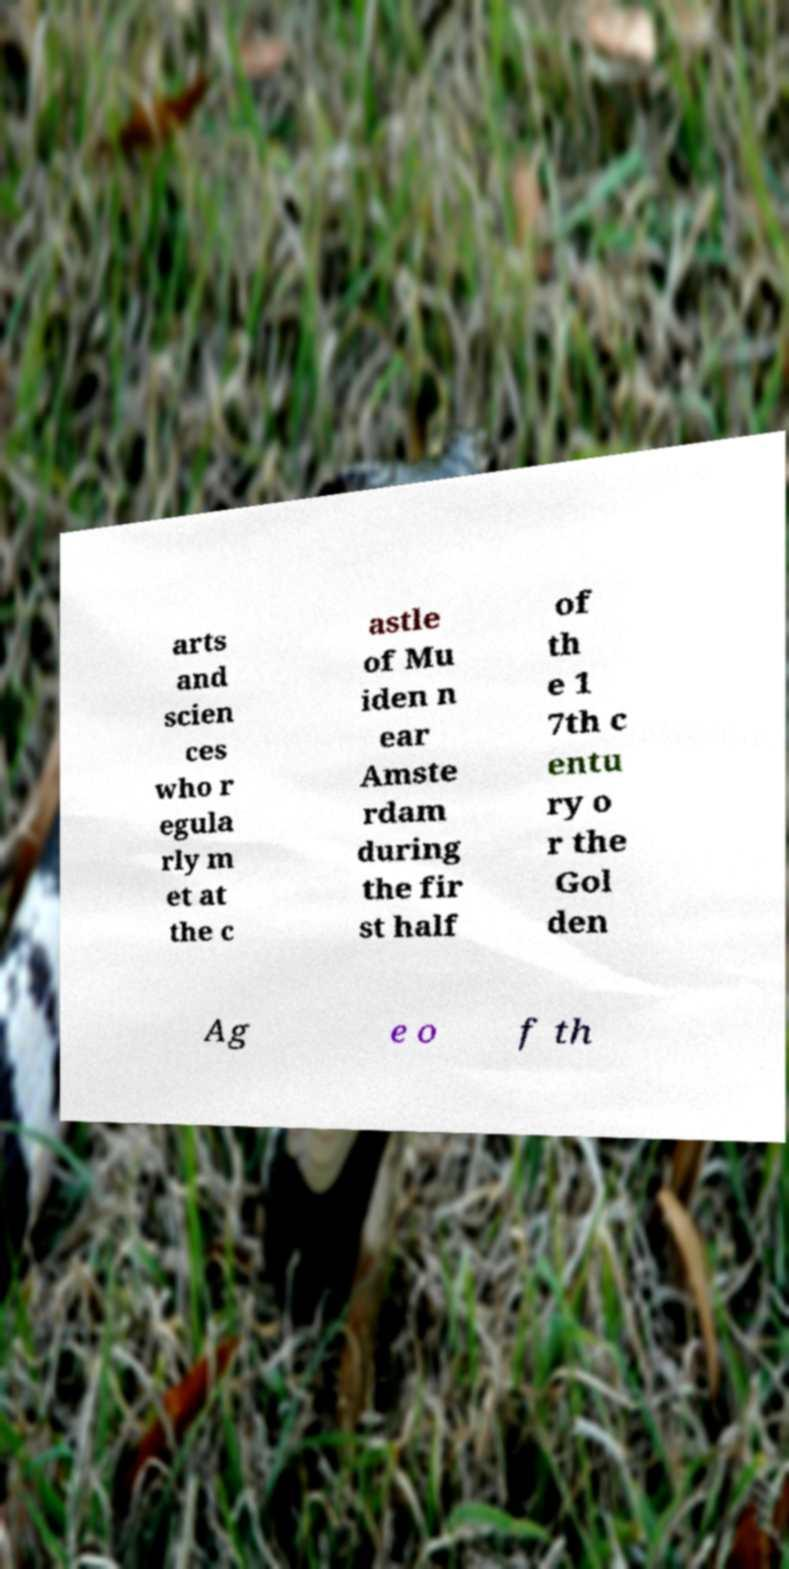Can you accurately transcribe the text from the provided image for me? arts and scien ces who r egula rly m et at the c astle of Mu iden n ear Amste rdam during the fir st half of th e 1 7th c entu ry o r the Gol den Ag e o f th 